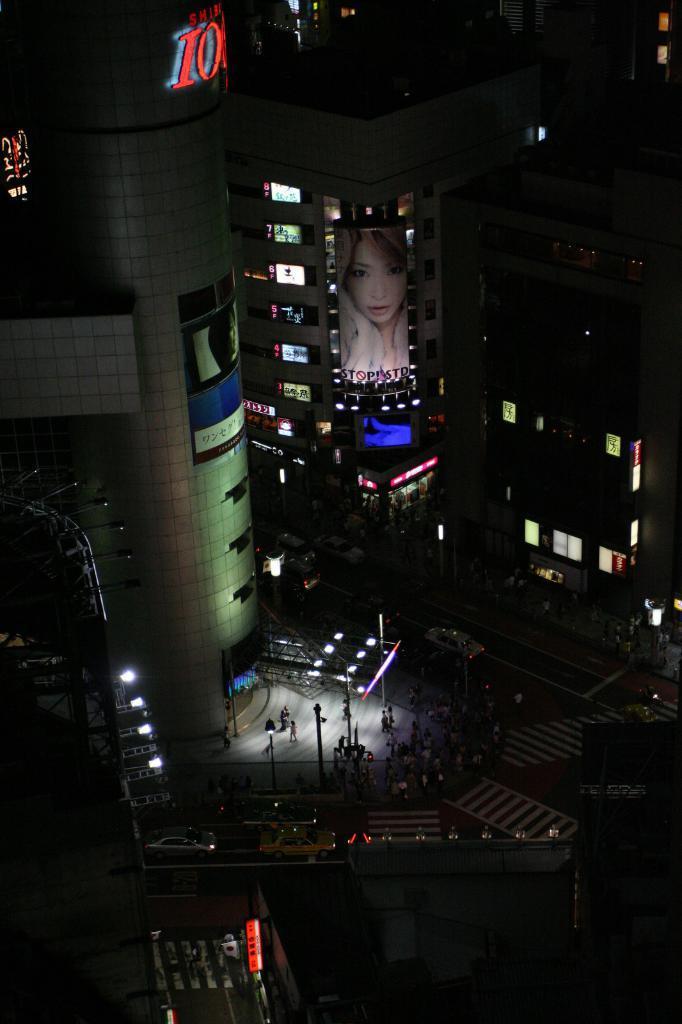In one or two sentences, can you explain what this image depicts? This image is taken outdoors. This image is a little dark. In this image there are many buildings. At the bottom of the image there is a road. There is a signal light. A few vehicles are moving on the road. A few people are walking on the road. 